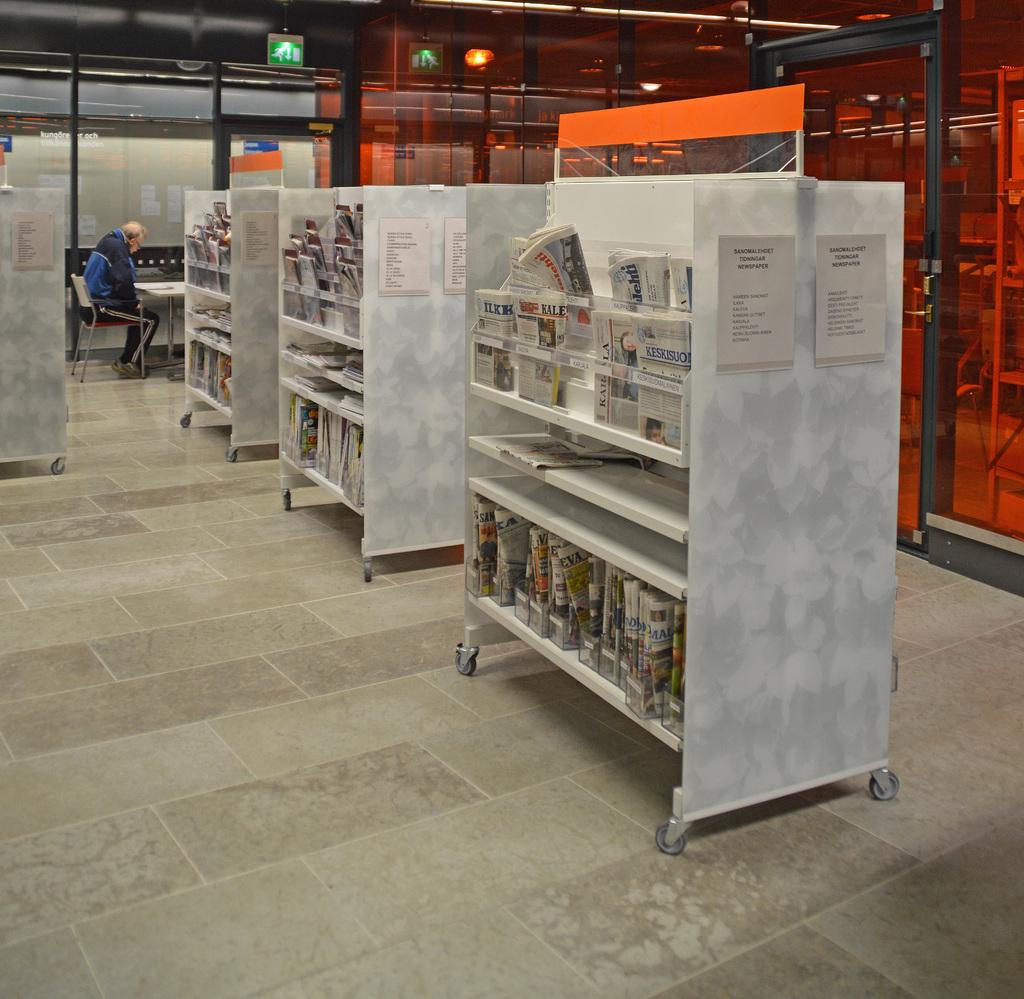<image>
Summarize the visual content of the image. the word newspaper is on the white paper 